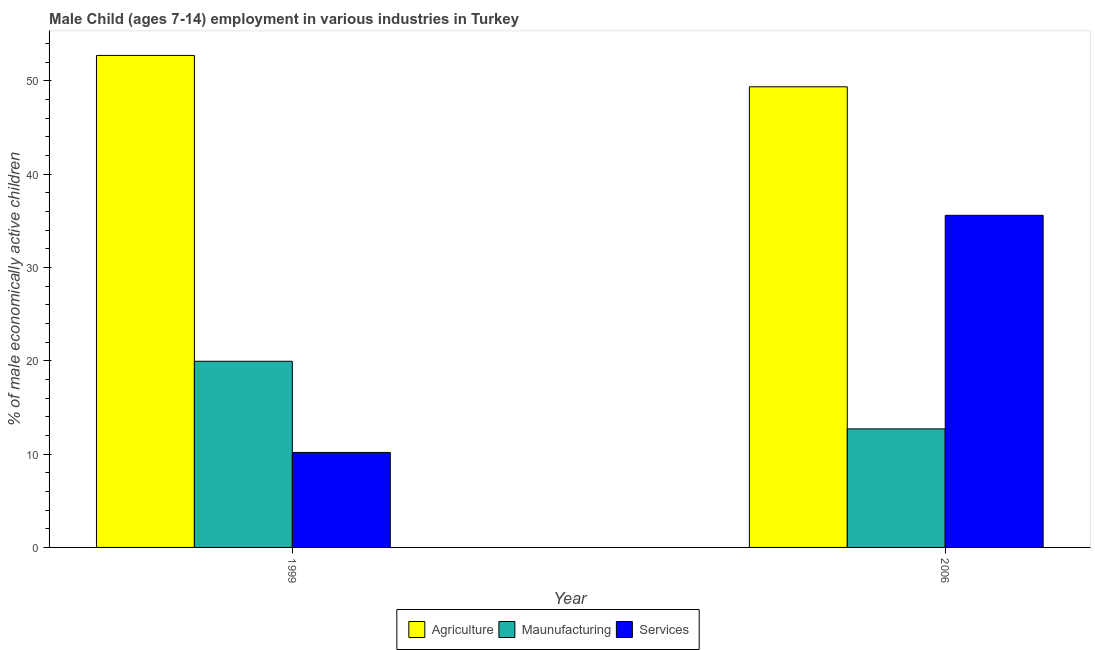Are the number of bars per tick equal to the number of legend labels?
Provide a succinct answer. Yes. Are the number of bars on each tick of the X-axis equal?
Your answer should be compact. Yes. How many bars are there on the 1st tick from the right?
Give a very brief answer. 3. What is the label of the 1st group of bars from the left?
Your answer should be compact. 1999. What is the percentage of economically active children in agriculture in 2006?
Your answer should be compact. 49.35. Across all years, what is the maximum percentage of economically active children in manufacturing?
Your answer should be very brief. 19.94. In which year was the percentage of economically active children in agriculture minimum?
Your response must be concise. 2006. What is the total percentage of economically active children in manufacturing in the graph?
Offer a terse response. 32.64. What is the difference between the percentage of economically active children in services in 1999 and that in 2006?
Ensure brevity in your answer.  -25.4. What is the difference between the percentage of economically active children in agriculture in 1999 and the percentage of economically active children in services in 2006?
Provide a succinct answer. 3.36. What is the average percentage of economically active children in agriculture per year?
Keep it short and to the point. 51.03. In the year 2006, what is the difference between the percentage of economically active children in agriculture and percentage of economically active children in services?
Give a very brief answer. 0. What is the ratio of the percentage of economically active children in manufacturing in 1999 to that in 2006?
Give a very brief answer. 1.57. Is the percentage of economically active children in manufacturing in 1999 less than that in 2006?
Make the answer very short. No. What does the 3rd bar from the left in 1999 represents?
Ensure brevity in your answer.  Services. What does the 2nd bar from the right in 1999 represents?
Make the answer very short. Maunufacturing. Is it the case that in every year, the sum of the percentage of economically active children in agriculture and percentage of economically active children in manufacturing is greater than the percentage of economically active children in services?
Your answer should be compact. Yes. How many years are there in the graph?
Offer a terse response. 2. Does the graph contain grids?
Provide a short and direct response. No. Where does the legend appear in the graph?
Keep it short and to the point. Bottom center. How many legend labels are there?
Give a very brief answer. 3. How are the legend labels stacked?
Provide a short and direct response. Horizontal. What is the title of the graph?
Offer a very short reply. Male Child (ages 7-14) employment in various industries in Turkey. What is the label or title of the Y-axis?
Provide a succinct answer. % of male economically active children. What is the % of male economically active children of Agriculture in 1999?
Your answer should be compact. 52.71. What is the % of male economically active children of Maunufacturing in 1999?
Your answer should be compact. 19.94. What is the % of male economically active children of Services in 1999?
Make the answer very short. 10.18. What is the % of male economically active children in Agriculture in 2006?
Your answer should be compact. 49.35. What is the % of male economically active children in Maunufacturing in 2006?
Ensure brevity in your answer.  12.7. What is the % of male economically active children in Services in 2006?
Ensure brevity in your answer.  35.58. Across all years, what is the maximum % of male economically active children in Agriculture?
Your answer should be very brief. 52.71. Across all years, what is the maximum % of male economically active children in Maunufacturing?
Offer a terse response. 19.94. Across all years, what is the maximum % of male economically active children of Services?
Keep it short and to the point. 35.58. Across all years, what is the minimum % of male economically active children in Agriculture?
Offer a terse response. 49.35. Across all years, what is the minimum % of male economically active children in Services?
Keep it short and to the point. 10.18. What is the total % of male economically active children in Agriculture in the graph?
Provide a succinct answer. 102.06. What is the total % of male economically active children of Maunufacturing in the graph?
Offer a terse response. 32.64. What is the total % of male economically active children of Services in the graph?
Keep it short and to the point. 45.76. What is the difference between the % of male economically active children of Agriculture in 1999 and that in 2006?
Make the answer very short. 3.36. What is the difference between the % of male economically active children of Maunufacturing in 1999 and that in 2006?
Ensure brevity in your answer.  7.24. What is the difference between the % of male economically active children of Services in 1999 and that in 2006?
Offer a very short reply. -25.4. What is the difference between the % of male economically active children in Agriculture in 1999 and the % of male economically active children in Maunufacturing in 2006?
Your response must be concise. 40.01. What is the difference between the % of male economically active children in Agriculture in 1999 and the % of male economically active children in Services in 2006?
Offer a terse response. 17.13. What is the difference between the % of male economically active children of Maunufacturing in 1999 and the % of male economically active children of Services in 2006?
Your response must be concise. -15.64. What is the average % of male economically active children of Agriculture per year?
Provide a succinct answer. 51.03. What is the average % of male economically active children in Maunufacturing per year?
Offer a very short reply. 16.32. What is the average % of male economically active children of Services per year?
Provide a succinct answer. 22.88. In the year 1999, what is the difference between the % of male economically active children of Agriculture and % of male economically active children of Maunufacturing?
Your response must be concise. 32.77. In the year 1999, what is the difference between the % of male economically active children in Agriculture and % of male economically active children in Services?
Offer a very short reply. 42.53. In the year 1999, what is the difference between the % of male economically active children in Maunufacturing and % of male economically active children in Services?
Ensure brevity in your answer.  9.77. In the year 2006, what is the difference between the % of male economically active children of Agriculture and % of male economically active children of Maunufacturing?
Give a very brief answer. 36.65. In the year 2006, what is the difference between the % of male economically active children in Agriculture and % of male economically active children in Services?
Offer a terse response. 13.77. In the year 2006, what is the difference between the % of male economically active children in Maunufacturing and % of male economically active children in Services?
Offer a very short reply. -22.88. What is the ratio of the % of male economically active children of Agriculture in 1999 to that in 2006?
Offer a very short reply. 1.07. What is the ratio of the % of male economically active children of Maunufacturing in 1999 to that in 2006?
Offer a very short reply. 1.57. What is the ratio of the % of male economically active children in Services in 1999 to that in 2006?
Provide a succinct answer. 0.29. What is the difference between the highest and the second highest % of male economically active children of Agriculture?
Provide a short and direct response. 3.36. What is the difference between the highest and the second highest % of male economically active children in Maunufacturing?
Give a very brief answer. 7.24. What is the difference between the highest and the second highest % of male economically active children in Services?
Provide a short and direct response. 25.4. What is the difference between the highest and the lowest % of male economically active children of Agriculture?
Keep it short and to the point. 3.36. What is the difference between the highest and the lowest % of male economically active children of Maunufacturing?
Ensure brevity in your answer.  7.24. What is the difference between the highest and the lowest % of male economically active children in Services?
Your answer should be very brief. 25.4. 